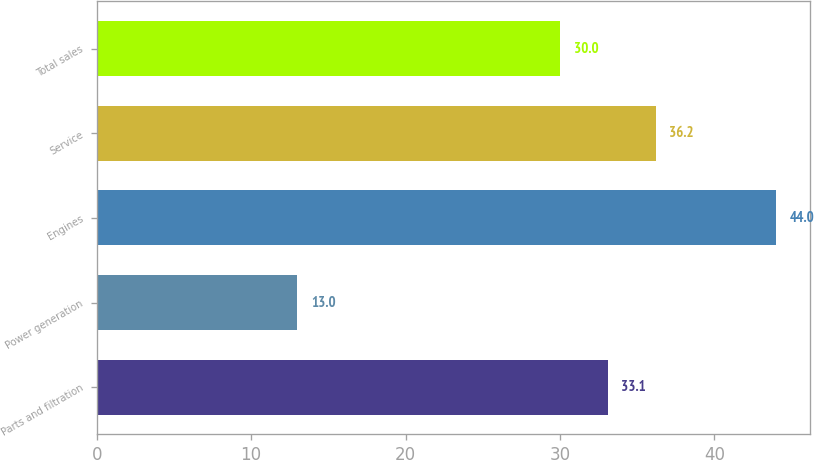Convert chart to OTSL. <chart><loc_0><loc_0><loc_500><loc_500><bar_chart><fcel>Parts and filtration<fcel>Power generation<fcel>Engines<fcel>Service<fcel>Total sales<nl><fcel>33.1<fcel>13<fcel>44<fcel>36.2<fcel>30<nl></chart> 